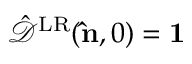Convert formula to latex. <formula><loc_0><loc_0><loc_500><loc_500>\hat { \mathcal { D } } ^ { L R } ( { \hat { n } } , 0 ) = { 1 }</formula> 